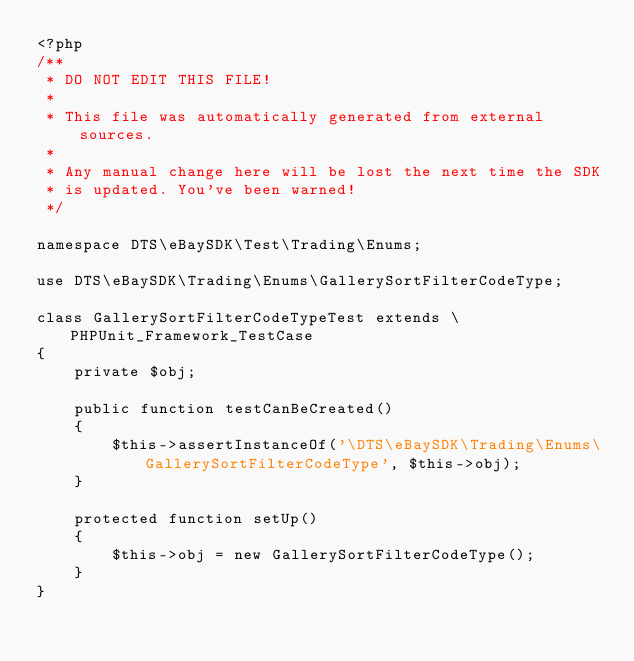Convert code to text. <code><loc_0><loc_0><loc_500><loc_500><_PHP_><?php
/**
 * DO NOT EDIT THIS FILE!
 *
 * This file was automatically generated from external sources.
 *
 * Any manual change here will be lost the next time the SDK
 * is updated. You've been warned!
 */

namespace DTS\eBaySDK\Test\Trading\Enums;

use DTS\eBaySDK\Trading\Enums\GallerySortFilterCodeType;

class GallerySortFilterCodeTypeTest extends \PHPUnit_Framework_TestCase
{
    private $obj;

    public function testCanBeCreated()
    {
        $this->assertInstanceOf('\DTS\eBaySDK\Trading\Enums\GallerySortFilterCodeType', $this->obj);
    }

    protected function setUp()
    {
        $this->obj = new GallerySortFilterCodeType();
    }
}
</code> 